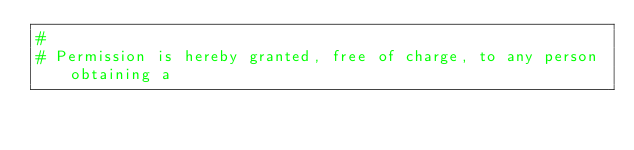<code> <loc_0><loc_0><loc_500><loc_500><_Python_>#
# Permission is hereby granted, free of charge, to any person obtaining a</code> 